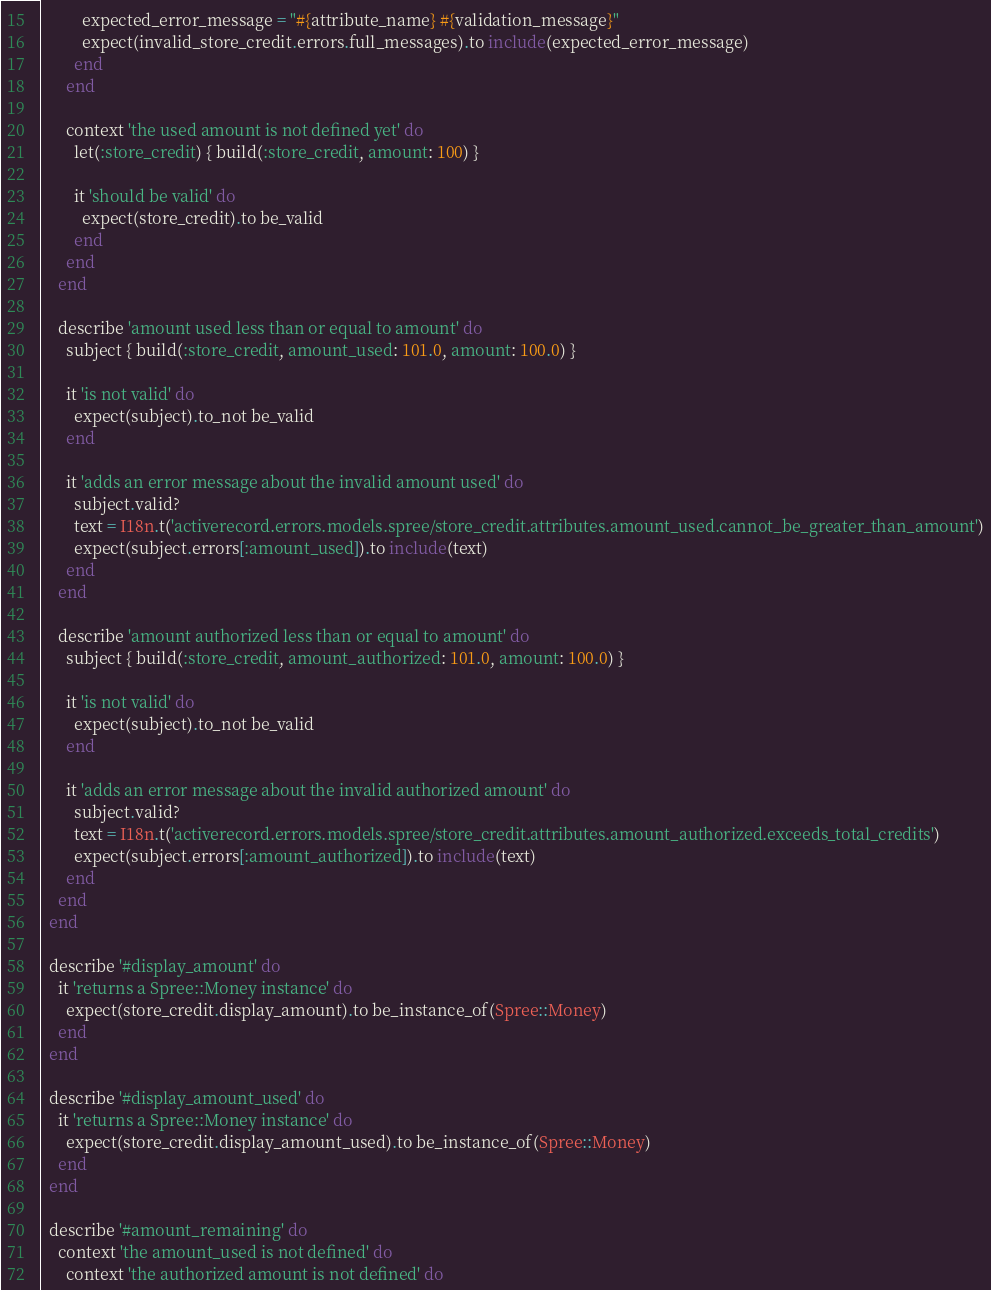<code> <loc_0><loc_0><loc_500><loc_500><_Ruby_>          expected_error_message = "#{attribute_name} #{validation_message}"
          expect(invalid_store_credit.errors.full_messages).to include(expected_error_message)
        end
      end

      context 'the used amount is not defined yet' do
        let(:store_credit) { build(:store_credit, amount: 100) }

        it 'should be valid' do
          expect(store_credit).to be_valid
        end
      end
    end

    describe 'amount used less than or equal to amount' do
      subject { build(:store_credit, amount_used: 101.0, amount: 100.0) }

      it 'is not valid' do
        expect(subject).to_not be_valid
      end

      it 'adds an error message about the invalid amount used' do
        subject.valid?
        text = I18n.t('activerecord.errors.models.spree/store_credit.attributes.amount_used.cannot_be_greater_than_amount')
        expect(subject.errors[:amount_used]).to include(text)
      end
    end

    describe 'amount authorized less than or equal to amount' do
      subject { build(:store_credit, amount_authorized: 101.0, amount: 100.0) }

      it 'is not valid' do
        expect(subject).to_not be_valid
      end

      it 'adds an error message about the invalid authorized amount' do
        subject.valid?
        text = I18n.t('activerecord.errors.models.spree/store_credit.attributes.amount_authorized.exceeds_total_credits')
        expect(subject.errors[:amount_authorized]).to include(text)
      end
    end
  end

  describe '#display_amount' do
    it 'returns a Spree::Money instance' do
      expect(store_credit.display_amount).to be_instance_of(Spree::Money)
    end
  end

  describe '#display_amount_used' do
    it 'returns a Spree::Money instance' do
      expect(store_credit.display_amount_used).to be_instance_of(Spree::Money)
    end
  end

  describe '#amount_remaining' do
    context 'the amount_used is not defined' do
      context 'the authorized amount is not defined' do</code> 